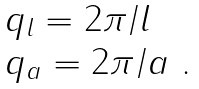<formula> <loc_0><loc_0><loc_500><loc_500>\ \begin{array} { l } q _ { l } = 2 \pi / l \\ q _ { a } = 2 \pi / a \ . \end{array}</formula> 